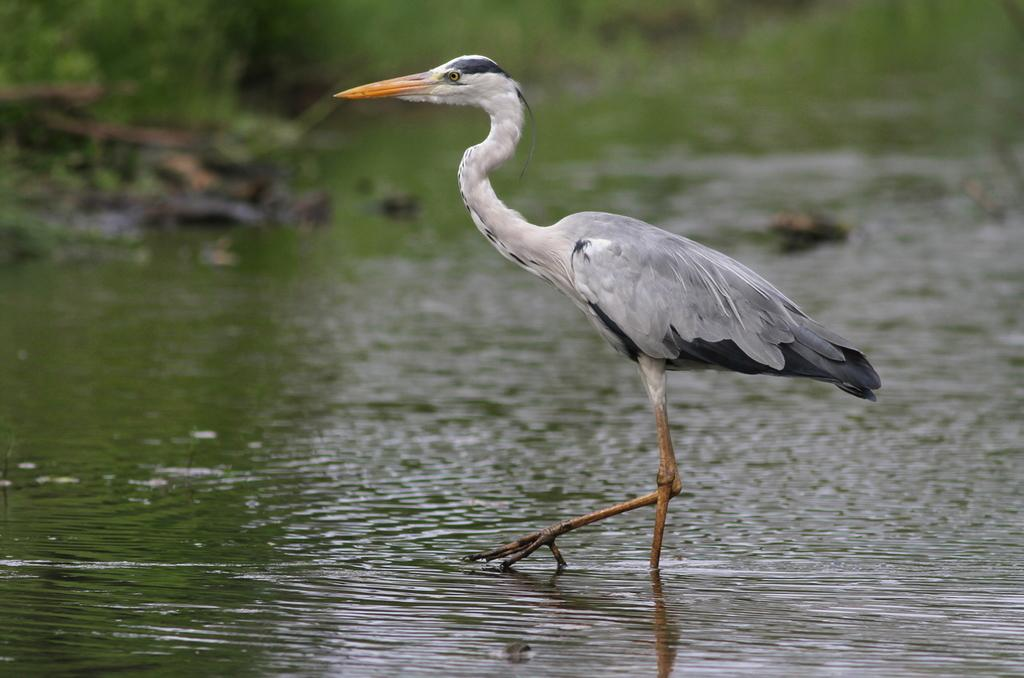What type of animal can be seen in the image? There is a bird in the image. Where is the bird located in the image? The bird is standing on the water. Can you describe the background of the image? The background of the image is slightly blurred. What reward does the bird receive after successfully completing its task in the image? There is no indication in the image that the bird is completing a task or receiving a reward. 